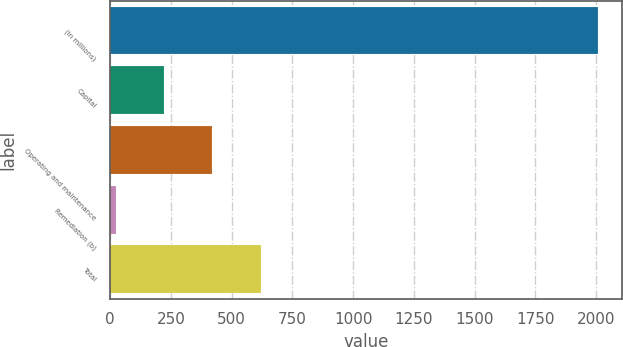Convert chart to OTSL. <chart><loc_0><loc_0><loc_500><loc_500><bar_chart><fcel>(In millions)<fcel>Capital<fcel>Operating and maintenance<fcel>Remediation (b)<fcel>Total<nl><fcel>2007<fcel>223.2<fcel>421.4<fcel>25<fcel>619.6<nl></chart> 